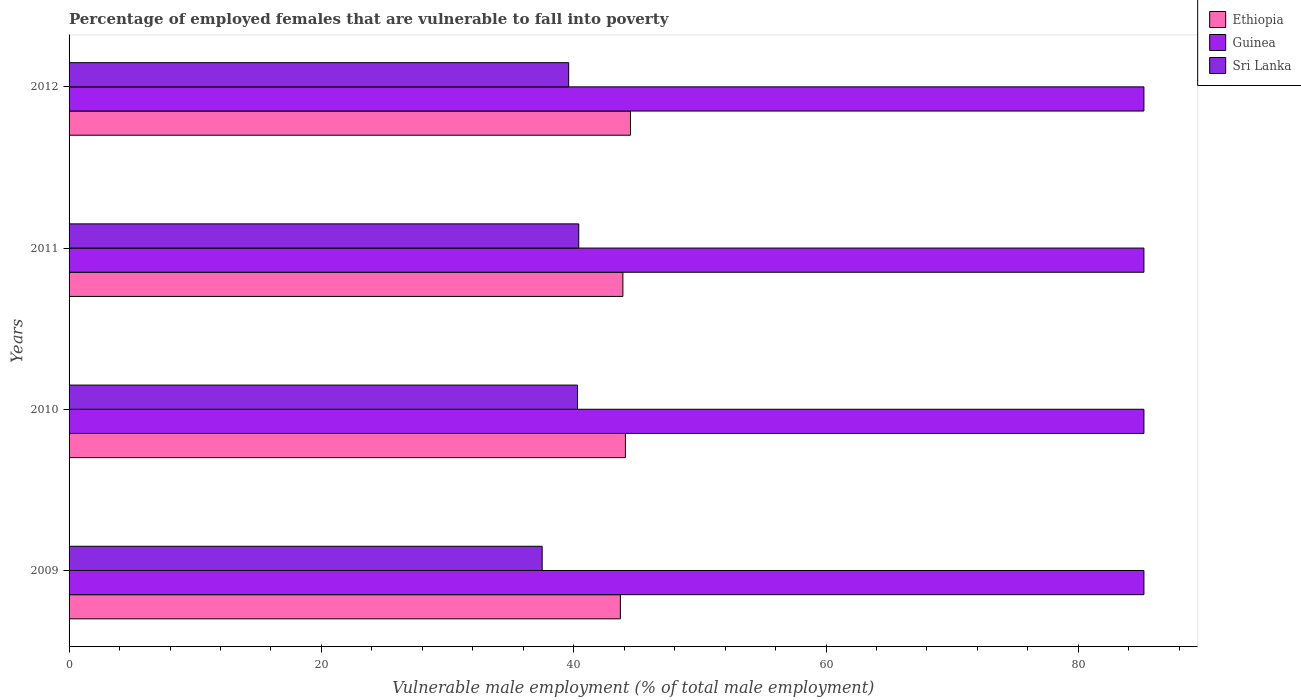Are the number of bars per tick equal to the number of legend labels?
Your answer should be very brief. Yes. How many bars are there on the 3rd tick from the bottom?
Provide a short and direct response. 3. What is the percentage of employed females who are vulnerable to fall into poverty in Sri Lanka in 2011?
Your answer should be very brief. 40.4. Across all years, what is the maximum percentage of employed females who are vulnerable to fall into poverty in Sri Lanka?
Your answer should be very brief. 40.4. Across all years, what is the minimum percentage of employed females who are vulnerable to fall into poverty in Sri Lanka?
Make the answer very short. 37.5. What is the total percentage of employed females who are vulnerable to fall into poverty in Sri Lanka in the graph?
Make the answer very short. 157.8. What is the difference between the percentage of employed females who are vulnerable to fall into poverty in Sri Lanka in 2010 and that in 2012?
Your answer should be compact. 0.7. What is the difference between the percentage of employed females who are vulnerable to fall into poverty in Guinea in 2010 and the percentage of employed females who are vulnerable to fall into poverty in Ethiopia in 2012?
Offer a terse response. 40.7. What is the average percentage of employed females who are vulnerable to fall into poverty in Ethiopia per year?
Provide a short and direct response. 44.05. In the year 2012, what is the difference between the percentage of employed females who are vulnerable to fall into poverty in Guinea and percentage of employed females who are vulnerable to fall into poverty in Ethiopia?
Provide a short and direct response. 40.7. In how many years, is the percentage of employed females who are vulnerable to fall into poverty in Ethiopia greater than 52 %?
Make the answer very short. 0. Is the percentage of employed females who are vulnerable to fall into poverty in Guinea in 2009 less than that in 2011?
Keep it short and to the point. No. What is the difference between the highest and the second highest percentage of employed females who are vulnerable to fall into poverty in Sri Lanka?
Offer a very short reply. 0.1. What is the difference between the highest and the lowest percentage of employed females who are vulnerable to fall into poverty in Sri Lanka?
Your answer should be very brief. 2.9. In how many years, is the percentage of employed females who are vulnerable to fall into poverty in Guinea greater than the average percentage of employed females who are vulnerable to fall into poverty in Guinea taken over all years?
Give a very brief answer. 0. Is the sum of the percentage of employed females who are vulnerable to fall into poverty in Guinea in 2009 and 2012 greater than the maximum percentage of employed females who are vulnerable to fall into poverty in Sri Lanka across all years?
Offer a very short reply. Yes. What does the 1st bar from the top in 2011 represents?
Give a very brief answer. Sri Lanka. What does the 2nd bar from the bottom in 2012 represents?
Your response must be concise. Guinea. What is the difference between two consecutive major ticks on the X-axis?
Offer a very short reply. 20. Does the graph contain any zero values?
Offer a terse response. No. Where does the legend appear in the graph?
Your response must be concise. Top right. How many legend labels are there?
Give a very brief answer. 3. How are the legend labels stacked?
Provide a succinct answer. Vertical. What is the title of the graph?
Your answer should be very brief. Percentage of employed females that are vulnerable to fall into poverty. What is the label or title of the X-axis?
Your answer should be very brief. Vulnerable male employment (% of total male employment). What is the Vulnerable male employment (% of total male employment) in Ethiopia in 2009?
Offer a very short reply. 43.7. What is the Vulnerable male employment (% of total male employment) in Guinea in 2009?
Offer a terse response. 85.2. What is the Vulnerable male employment (% of total male employment) in Sri Lanka in 2009?
Offer a terse response. 37.5. What is the Vulnerable male employment (% of total male employment) in Ethiopia in 2010?
Make the answer very short. 44.1. What is the Vulnerable male employment (% of total male employment) of Guinea in 2010?
Offer a very short reply. 85.2. What is the Vulnerable male employment (% of total male employment) of Sri Lanka in 2010?
Ensure brevity in your answer.  40.3. What is the Vulnerable male employment (% of total male employment) in Ethiopia in 2011?
Your answer should be compact. 43.9. What is the Vulnerable male employment (% of total male employment) of Guinea in 2011?
Provide a succinct answer. 85.2. What is the Vulnerable male employment (% of total male employment) in Sri Lanka in 2011?
Provide a succinct answer. 40.4. What is the Vulnerable male employment (% of total male employment) of Ethiopia in 2012?
Provide a succinct answer. 44.5. What is the Vulnerable male employment (% of total male employment) in Guinea in 2012?
Provide a succinct answer. 85.2. What is the Vulnerable male employment (% of total male employment) of Sri Lanka in 2012?
Your answer should be compact. 39.6. Across all years, what is the maximum Vulnerable male employment (% of total male employment) in Ethiopia?
Your answer should be very brief. 44.5. Across all years, what is the maximum Vulnerable male employment (% of total male employment) of Guinea?
Make the answer very short. 85.2. Across all years, what is the maximum Vulnerable male employment (% of total male employment) of Sri Lanka?
Your answer should be very brief. 40.4. Across all years, what is the minimum Vulnerable male employment (% of total male employment) in Ethiopia?
Provide a succinct answer. 43.7. Across all years, what is the minimum Vulnerable male employment (% of total male employment) of Guinea?
Keep it short and to the point. 85.2. Across all years, what is the minimum Vulnerable male employment (% of total male employment) in Sri Lanka?
Keep it short and to the point. 37.5. What is the total Vulnerable male employment (% of total male employment) of Ethiopia in the graph?
Your response must be concise. 176.2. What is the total Vulnerable male employment (% of total male employment) of Guinea in the graph?
Offer a very short reply. 340.8. What is the total Vulnerable male employment (% of total male employment) in Sri Lanka in the graph?
Keep it short and to the point. 157.8. What is the difference between the Vulnerable male employment (% of total male employment) of Guinea in 2009 and that in 2010?
Your answer should be very brief. 0. What is the difference between the Vulnerable male employment (% of total male employment) of Ethiopia in 2009 and that in 2011?
Make the answer very short. -0.2. What is the difference between the Vulnerable male employment (% of total male employment) of Ethiopia in 2009 and that in 2012?
Your answer should be very brief. -0.8. What is the difference between the Vulnerable male employment (% of total male employment) in Ethiopia in 2010 and that in 2011?
Your answer should be very brief. 0.2. What is the difference between the Vulnerable male employment (% of total male employment) in Guinea in 2010 and that in 2011?
Your answer should be compact. 0. What is the difference between the Vulnerable male employment (% of total male employment) in Sri Lanka in 2010 and that in 2011?
Ensure brevity in your answer.  -0.1. What is the difference between the Vulnerable male employment (% of total male employment) in Ethiopia in 2010 and that in 2012?
Offer a terse response. -0.4. What is the difference between the Vulnerable male employment (% of total male employment) in Guinea in 2011 and that in 2012?
Keep it short and to the point. 0. What is the difference between the Vulnerable male employment (% of total male employment) in Sri Lanka in 2011 and that in 2012?
Your answer should be compact. 0.8. What is the difference between the Vulnerable male employment (% of total male employment) in Ethiopia in 2009 and the Vulnerable male employment (% of total male employment) in Guinea in 2010?
Your answer should be compact. -41.5. What is the difference between the Vulnerable male employment (% of total male employment) of Guinea in 2009 and the Vulnerable male employment (% of total male employment) of Sri Lanka in 2010?
Offer a very short reply. 44.9. What is the difference between the Vulnerable male employment (% of total male employment) in Ethiopia in 2009 and the Vulnerable male employment (% of total male employment) in Guinea in 2011?
Make the answer very short. -41.5. What is the difference between the Vulnerable male employment (% of total male employment) of Ethiopia in 2009 and the Vulnerable male employment (% of total male employment) of Sri Lanka in 2011?
Ensure brevity in your answer.  3.3. What is the difference between the Vulnerable male employment (% of total male employment) in Guinea in 2009 and the Vulnerable male employment (% of total male employment) in Sri Lanka in 2011?
Offer a very short reply. 44.8. What is the difference between the Vulnerable male employment (% of total male employment) of Ethiopia in 2009 and the Vulnerable male employment (% of total male employment) of Guinea in 2012?
Ensure brevity in your answer.  -41.5. What is the difference between the Vulnerable male employment (% of total male employment) of Guinea in 2009 and the Vulnerable male employment (% of total male employment) of Sri Lanka in 2012?
Provide a succinct answer. 45.6. What is the difference between the Vulnerable male employment (% of total male employment) in Ethiopia in 2010 and the Vulnerable male employment (% of total male employment) in Guinea in 2011?
Ensure brevity in your answer.  -41.1. What is the difference between the Vulnerable male employment (% of total male employment) of Ethiopia in 2010 and the Vulnerable male employment (% of total male employment) of Sri Lanka in 2011?
Offer a very short reply. 3.7. What is the difference between the Vulnerable male employment (% of total male employment) of Guinea in 2010 and the Vulnerable male employment (% of total male employment) of Sri Lanka in 2011?
Your answer should be compact. 44.8. What is the difference between the Vulnerable male employment (% of total male employment) of Ethiopia in 2010 and the Vulnerable male employment (% of total male employment) of Guinea in 2012?
Provide a succinct answer. -41.1. What is the difference between the Vulnerable male employment (% of total male employment) in Ethiopia in 2010 and the Vulnerable male employment (% of total male employment) in Sri Lanka in 2012?
Your response must be concise. 4.5. What is the difference between the Vulnerable male employment (% of total male employment) of Guinea in 2010 and the Vulnerable male employment (% of total male employment) of Sri Lanka in 2012?
Provide a succinct answer. 45.6. What is the difference between the Vulnerable male employment (% of total male employment) of Ethiopia in 2011 and the Vulnerable male employment (% of total male employment) of Guinea in 2012?
Offer a terse response. -41.3. What is the difference between the Vulnerable male employment (% of total male employment) in Guinea in 2011 and the Vulnerable male employment (% of total male employment) in Sri Lanka in 2012?
Keep it short and to the point. 45.6. What is the average Vulnerable male employment (% of total male employment) of Ethiopia per year?
Offer a terse response. 44.05. What is the average Vulnerable male employment (% of total male employment) of Guinea per year?
Provide a succinct answer. 85.2. What is the average Vulnerable male employment (% of total male employment) in Sri Lanka per year?
Give a very brief answer. 39.45. In the year 2009, what is the difference between the Vulnerable male employment (% of total male employment) of Ethiopia and Vulnerable male employment (% of total male employment) of Guinea?
Give a very brief answer. -41.5. In the year 2009, what is the difference between the Vulnerable male employment (% of total male employment) of Ethiopia and Vulnerable male employment (% of total male employment) of Sri Lanka?
Provide a short and direct response. 6.2. In the year 2009, what is the difference between the Vulnerable male employment (% of total male employment) of Guinea and Vulnerable male employment (% of total male employment) of Sri Lanka?
Provide a succinct answer. 47.7. In the year 2010, what is the difference between the Vulnerable male employment (% of total male employment) of Ethiopia and Vulnerable male employment (% of total male employment) of Guinea?
Your answer should be compact. -41.1. In the year 2010, what is the difference between the Vulnerable male employment (% of total male employment) in Ethiopia and Vulnerable male employment (% of total male employment) in Sri Lanka?
Make the answer very short. 3.8. In the year 2010, what is the difference between the Vulnerable male employment (% of total male employment) in Guinea and Vulnerable male employment (% of total male employment) in Sri Lanka?
Keep it short and to the point. 44.9. In the year 2011, what is the difference between the Vulnerable male employment (% of total male employment) of Ethiopia and Vulnerable male employment (% of total male employment) of Guinea?
Make the answer very short. -41.3. In the year 2011, what is the difference between the Vulnerable male employment (% of total male employment) of Ethiopia and Vulnerable male employment (% of total male employment) of Sri Lanka?
Your response must be concise. 3.5. In the year 2011, what is the difference between the Vulnerable male employment (% of total male employment) of Guinea and Vulnerable male employment (% of total male employment) of Sri Lanka?
Your answer should be compact. 44.8. In the year 2012, what is the difference between the Vulnerable male employment (% of total male employment) in Ethiopia and Vulnerable male employment (% of total male employment) in Guinea?
Make the answer very short. -40.7. In the year 2012, what is the difference between the Vulnerable male employment (% of total male employment) of Guinea and Vulnerable male employment (% of total male employment) of Sri Lanka?
Keep it short and to the point. 45.6. What is the ratio of the Vulnerable male employment (% of total male employment) in Ethiopia in 2009 to that in 2010?
Your answer should be very brief. 0.99. What is the ratio of the Vulnerable male employment (% of total male employment) in Sri Lanka in 2009 to that in 2010?
Provide a succinct answer. 0.93. What is the ratio of the Vulnerable male employment (% of total male employment) in Sri Lanka in 2009 to that in 2011?
Provide a short and direct response. 0.93. What is the ratio of the Vulnerable male employment (% of total male employment) of Ethiopia in 2009 to that in 2012?
Make the answer very short. 0.98. What is the ratio of the Vulnerable male employment (% of total male employment) in Sri Lanka in 2009 to that in 2012?
Give a very brief answer. 0.95. What is the ratio of the Vulnerable male employment (% of total male employment) in Ethiopia in 2010 to that in 2011?
Keep it short and to the point. 1. What is the ratio of the Vulnerable male employment (% of total male employment) of Guinea in 2010 to that in 2011?
Ensure brevity in your answer.  1. What is the ratio of the Vulnerable male employment (% of total male employment) in Sri Lanka in 2010 to that in 2011?
Your answer should be very brief. 1. What is the ratio of the Vulnerable male employment (% of total male employment) in Ethiopia in 2010 to that in 2012?
Provide a short and direct response. 0.99. What is the ratio of the Vulnerable male employment (% of total male employment) of Sri Lanka in 2010 to that in 2012?
Provide a short and direct response. 1.02. What is the ratio of the Vulnerable male employment (% of total male employment) of Ethiopia in 2011 to that in 2012?
Your answer should be compact. 0.99. What is the ratio of the Vulnerable male employment (% of total male employment) of Guinea in 2011 to that in 2012?
Your answer should be very brief. 1. What is the ratio of the Vulnerable male employment (% of total male employment) of Sri Lanka in 2011 to that in 2012?
Your response must be concise. 1.02. What is the difference between the highest and the lowest Vulnerable male employment (% of total male employment) in Ethiopia?
Provide a succinct answer. 0.8. What is the difference between the highest and the lowest Vulnerable male employment (% of total male employment) of Guinea?
Ensure brevity in your answer.  0. 